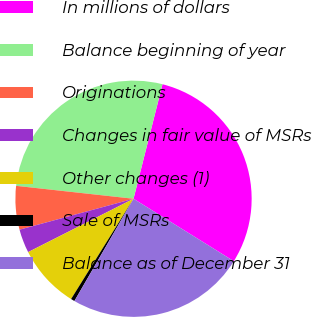<chart> <loc_0><loc_0><loc_500><loc_500><pie_chart><fcel>In millions of dollars<fcel>Balance beginning of year<fcel>Originations<fcel>Changes in fair value of MSRs<fcel>Other changes (1)<fcel>Sale of MSRs<fcel>Balance as of December 31<nl><fcel>29.92%<fcel>27.2%<fcel>5.96%<fcel>3.24%<fcel>8.68%<fcel>0.52%<fcel>24.48%<nl></chart> 